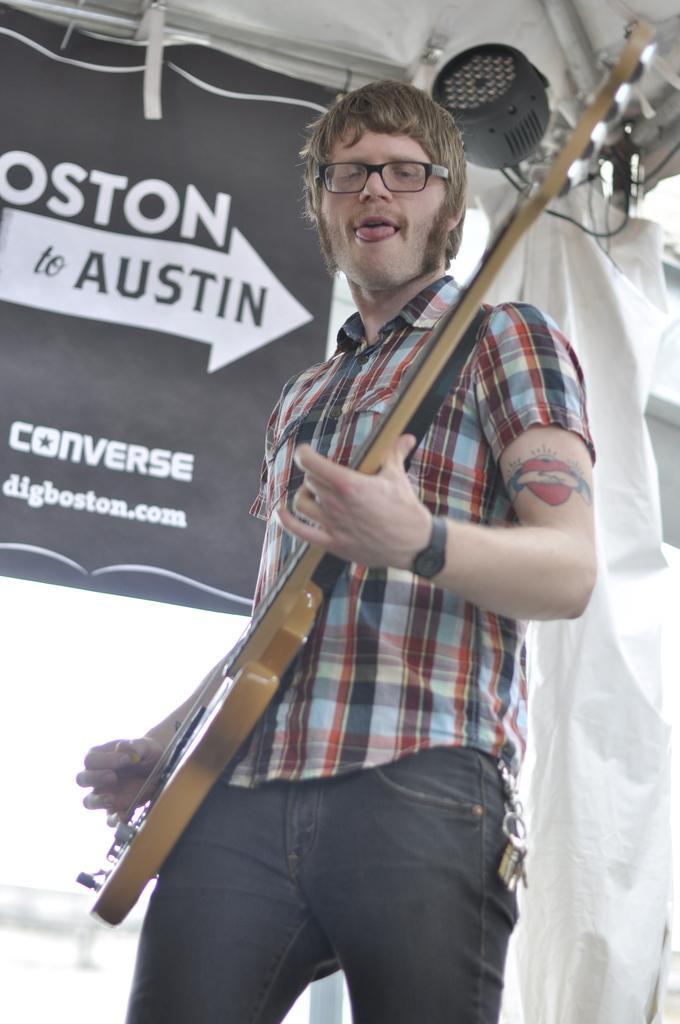Could you give a brief overview of what you see in this image? A person is standing and playing guitar. There is a tattoo on his hand. There is a banner and a light at the back. 